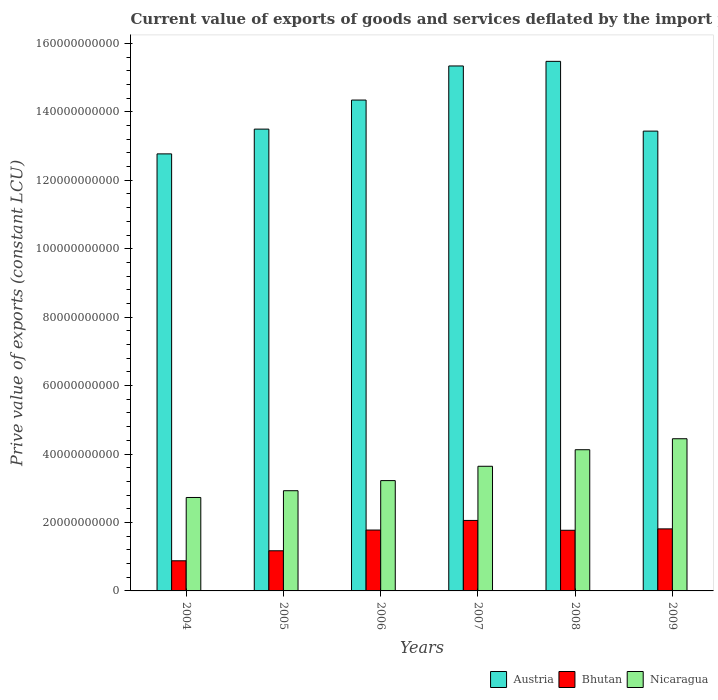How many different coloured bars are there?
Make the answer very short. 3. How many groups of bars are there?
Make the answer very short. 6. How many bars are there on the 1st tick from the right?
Offer a very short reply. 3. What is the prive value of exports in Bhutan in 2005?
Provide a short and direct response. 1.17e+1. Across all years, what is the maximum prive value of exports in Bhutan?
Give a very brief answer. 2.06e+1. Across all years, what is the minimum prive value of exports in Bhutan?
Your answer should be compact. 8.81e+09. In which year was the prive value of exports in Nicaragua maximum?
Provide a succinct answer. 2009. What is the total prive value of exports in Nicaragua in the graph?
Give a very brief answer. 2.11e+11. What is the difference between the prive value of exports in Nicaragua in 2008 and that in 2009?
Make the answer very short. -3.21e+09. What is the difference between the prive value of exports in Nicaragua in 2008 and the prive value of exports in Bhutan in 2009?
Your answer should be very brief. 2.31e+1. What is the average prive value of exports in Austria per year?
Ensure brevity in your answer.  1.41e+11. In the year 2006, what is the difference between the prive value of exports in Austria and prive value of exports in Bhutan?
Offer a terse response. 1.26e+11. In how many years, is the prive value of exports in Austria greater than 140000000000 LCU?
Offer a very short reply. 3. What is the ratio of the prive value of exports in Bhutan in 2007 to that in 2008?
Give a very brief answer. 1.16. Is the difference between the prive value of exports in Austria in 2004 and 2006 greater than the difference between the prive value of exports in Bhutan in 2004 and 2006?
Ensure brevity in your answer.  No. What is the difference between the highest and the second highest prive value of exports in Austria?
Ensure brevity in your answer.  1.35e+09. What is the difference between the highest and the lowest prive value of exports in Austria?
Provide a succinct answer. 2.70e+1. What does the 2nd bar from the left in 2008 represents?
Your answer should be compact. Bhutan. How many bars are there?
Offer a very short reply. 18. Are the values on the major ticks of Y-axis written in scientific E-notation?
Give a very brief answer. No. Does the graph contain grids?
Your response must be concise. No. How are the legend labels stacked?
Provide a succinct answer. Horizontal. What is the title of the graph?
Offer a terse response. Current value of exports of goods and services deflated by the import price index. What is the label or title of the X-axis?
Keep it short and to the point. Years. What is the label or title of the Y-axis?
Offer a very short reply. Prive value of exports (constant LCU). What is the Prive value of exports (constant LCU) of Austria in 2004?
Offer a terse response. 1.28e+11. What is the Prive value of exports (constant LCU) in Bhutan in 2004?
Offer a terse response. 8.81e+09. What is the Prive value of exports (constant LCU) of Nicaragua in 2004?
Keep it short and to the point. 2.73e+1. What is the Prive value of exports (constant LCU) of Austria in 2005?
Offer a terse response. 1.35e+11. What is the Prive value of exports (constant LCU) in Bhutan in 2005?
Provide a succinct answer. 1.17e+1. What is the Prive value of exports (constant LCU) in Nicaragua in 2005?
Ensure brevity in your answer.  2.93e+1. What is the Prive value of exports (constant LCU) in Austria in 2006?
Provide a succinct answer. 1.43e+11. What is the Prive value of exports (constant LCU) in Bhutan in 2006?
Your answer should be compact. 1.78e+1. What is the Prive value of exports (constant LCU) of Nicaragua in 2006?
Keep it short and to the point. 3.22e+1. What is the Prive value of exports (constant LCU) of Austria in 2007?
Your answer should be compact. 1.53e+11. What is the Prive value of exports (constant LCU) in Bhutan in 2007?
Make the answer very short. 2.06e+1. What is the Prive value of exports (constant LCU) in Nicaragua in 2007?
Your answer should be very brief. 3.64e+1. What is the Prive value of exports (constant LCU) in Austria in 2008?
Your response must be concise. 1.55e+11. What is the Prive value of exports (constant LCU) of Bhutan in 2008?
Keep it short and to the point. 1.77e+1. What is the Prive value of exports (constant LCU) in Nicaragua in 2008?
Provide a succinct answer. 4.13e+1. What is the Prive value of exports (constant LCU) in Austria in 2009?
Your answer should be compact. 1.34e+11. What is the Prive value of exports (constant LCU) in Bhutan in 2009?
Give a very brief answer. 1.81e+1. What is the Prive value of exports (constant LCU) in Nicaragua in 2009?
Provide a short and direct response. 4.45e+1. Across all years, what is the maximum Prive value of exports (constant LCU) of Austria?
Ensure brevity in your answer.  1.55e+11. Across all years, what is the maximum Prive value of exports (constant LCU) of Bhutan?
Your answer should be very brief. 2.06e+1. Across all years, what is the maximum Prive value of exports (constant LCU) in Nicaragua?
Offer a very short reply. 4.45e+1. Across all years, what is the minimum Prive value of exports (constant LCU) in Austria?
Provide a succinct answer. 1.28e+11. Across all years, what is the minimum Prive value of exports (constant LCU) in Bhutan?
Give a very brief answer. 8.81e+09. Across all years, what is the minimum Prive value of exports (constant LCU) in Nicaragua?
Provide a succinct answer. 2.73e+1. What is the total Prive value of exports (constant LCU) in Austria in the graph?
Offer a terse response. 8.49e+11. What is the total Prive value of exports (constant LCU) of Bhutan in the graph?
Offer a terse response. 9.48e+1. What is the total Prive value of exports (constant LCU) of Nicaragua in the graph?
Your response must be concise. 2.11e+11. What is the difference between the Prive value of exports (constant LCU) in Austria in 2004 and that in 2005?
Give a very brief answer. -7.24e+09. What is the difference between the Prive value of exports (constant LCU) in Bhutan in 2004 and that in 2005?
Your response must be concise. -2.92e+09. What is the difference between the Prive value of exports (constant LCU) in Nicaragua in 2004 and that in 2005?
Provide a short and direct response. -1.97e+09. What is the difference between the Prive value of exports (constant LCU) in Austria in 2004 and that in 2006?
Offer a terse response. -1.57e+1. What is the difference between the Prive value of exports (constant LCU) of Bhutan in 2004 and that in 2006?
Provide a succinct answer. -8.99e+09. What is the difference between the Prive value of exports (constant LCU) of Nicaragua in 2004 and that in 2006?
Your answer should be very brief. -4.93e+09. What is the difference between the Prive value of exports (constant LCU) in Austria in 2004 and that in 2007?
Your answer should be very brief. -2.57e+1. What is the difference between the Prive value of exports (constant LCU) of Bhutan in 2004 and that in 2007?
Give a very brief answer. -1.18e+1. What is the difference between the Prive value of exports (constant LCU) of Nicaragua in 2004 and that in 2007?
Ensure brevity in your answer.  -9.12e+09. What is the difference between the Prive value of exports (constant LCU) in Austria in 2004 and that in 2008?
Make the answer very short. -2.70e+1. What is the difference between the Prive value of exports (constant LCU) of Bhutan in 2004 and that in 2008?
Keep it short and to the point. -8.92e+09. What is the difference between the Prive value of exports (constant LCU) in Nicaragua in 2004 and that in 2008?
Your answer should be compact. -1.40e+1. What is the difference between the Prive value of exports (constant LCU) of Austria in 2004 and that in 2009?
Make the answer very short. -6.66e+09. What is the difference between the Prive value of exports (constant LCU) in Bhutan in 2004 and that in 2009?
Keep it short and to the point. -9.32e+09. What is the difference between the Prive value of exports (constant LCU) in Nicaragua in 2004 and that in 2009?
Provide a short and direct response. -1.72e+1. What is the difference between the Prive value of exports (constant LCU) of Austria in 2005 and that in 2006?
Provide a short and direct response. -8.49e+09. What is the difference between the Prive value of exports (constant LCU) in Bhutan in 2005 and that in 2006?
Offer a terse response. -6.06e+09. What is the difference between the Prive value of exports (constant LCU) in Nicaragua in 2005 and that in 2006?
Provide a short and direct response. -2.96e+09. What is the difference between the Prive value of exports (constant LCU) of Austria in 2005 and that in 2007?
Your response must be concise. -1.85e+1. What is the difference between the Prive value of exports (constant LCU) in Bhutan in 2005 and that in 2007?
Make the answer very short. -8.87e+09. What is the difference between the Prive value of exports (constant LCU) in Nicaragua in 2005 and that in 2007?
Keep it short and to the point. -7.14e+09. What is the difference between the Prive value of exports (constant LCU) in Austria in 2005 and that in 2008?
Keep it short and to the point. -1.98e+1. What is the difference between the Prive value of exports (constant LCU) of Bhutan in 2005 and that in 2008?
Keep it short and to the point. -5.99e+09. What is the difference between the Prive value of exports (constant LCU) in Nicaragua in 2005 and that in 2008?
Your answer should be very brief. -1.20e+1. What is the difference between the Prive value of exports (constant LCU) of Austria in 2005 and that in 2009?
Keep it short and to the point. 5.83e+08. What is the difference between the Prive value of exports (constant LCU) in Bhutan in 2005 and that in 2009?
Offer a very short reply. -6.40e+09. What is the difference between the Prive value of exports (constant LCU) of Nicaragua in 2005 and that in 2009?
Ensure brevity in your answer.  -1.52e+1. What is the difference between the Prive value of exports (constant LCU) in Austria in 2006 and that in 2007?
Offer a very short reply. -9.96e+09. What is the difference between the Prive value of exports (constant LCU) in Bhutan in 2006 and that in 2007?
Offer a very short reply. -2.81e+09. What is the difference between the Prive value of exports (constant LCU) in Nicaragua in 2006 and that in 2007?
Your response must be concise. -4.19e+09. What is the difference between the Prive value of exports (constant LCU) of Austria in 2006 and that in 2008?
Give a very brief answer. -1.13e+1. What is the difference between the Prive value of exports (constant LCU) in Bhutan in 2006 and that in 2008?
Keep it short and to the point. 7.04e+07. What is the difference between the Prive value of exports (constant LCU) of Nicaragua in 2006 and that in 2008?
Your answer should be very brief. -9.02e+09. What is the difference between the Prive value of exports (constant LCU) in Austria in 2006 and that in 2009?
Your answer should be compact. 9.08e+09. What is the difference between the Prive value of exports (constant LCU) in Bhutan in 2006 and that in 2009?
Ensure brevity in your answer.  -3.35e+08. What is the difference between the Prive value of exports (constant LCU) in Nicaragua in 2006 and that in 2009?
Offer a terse response. -1.22e+1. What is the difference between the Prive value of exports (constant LCU) of Austria in 2007 and that in 2008?
Ensure brevity in your answer.  -1.35e+09. What is the difference between the Prive value of exports (constant LCU) in Bhutan in 2007 and that in 2008?
Your answer should be very brief. 2.88e+09. What is the difference between the Prive value of exports (constant LCU) in Nicaragua in 2007 and that in 2008?
Your answer should be very brief. -4.84e+09. What is the difference between the Prive value of exports (constant LCU) in Austria in 2007 and that in 2009?
Your answer should be very brief. 1.90e+1. What is the difference between the Prive value of exports (constant LCU) in Bhutan in 2007 and that in 2009?
Your response must be concise. 2.47e+09. What is the difference between the Prive value of exports (constant LCU) in Nicaragua in 2007 and that in 2009?
Offer a very short reply. -8.05e+09. What is the difference between the Prive value of exports (constant LCU) in Austria in 2008 and that in 2009?
Give a very brief answer. 2.04e+1. What is the difference between the Prive value of exports (constant LCU) of Bhutan in 2008 and that in 2009?
Offer a terse response. -4.05e+08. What is the difference between the Prive value of exports (constant LCU) of Nicaragua in 2008 and that in 2009?
Provide a succinct answer. -3.21e+09. What is the difference between the Prive value of exports (constant LCU) in Austria in 2004 and the Prive value of exports (constant LCU) in Bhutan in 2005?
Make the answer very short. 1.16e+11. What is the difference between the Prive value of exports (constant LCU) in Austria in 2004 and the Prive value of exports (constant LCU) in Nicaragua in 2005?
Provide a succinct answer. 9.84e+1. What is the difference between the Prive value of exports (constant LCU) in Bhutan in 2004 and the Prive value of exports (constant LCU) in Nicaragua in 2005?
Offer a terse response. -2.05e+1. What is the difference between the Prive value of exports (constant LCU) in Austria in 2004 and the Prive value of exports (constant LCU) in Bhutan in 2006?
Your answer should be very brief. 1.10e+11. What is the difference between the Prive value of exports (constant LCU) of Austria in 2004 and the Prive value of exports (constant LCU) of Nicaragua in 2006?
Offer a terse response. 9.55e+1. What is the difference between the Prive value of exports (constant LCU) in Bhutan in 2004 and the Prive value of exports (constant LCU) in Nicaragua in 2006?
Your response must be concise. -2.34e+1. What is the difference between the Prive value of exports (constant LCU) in Austria in 2004 and the Prive value of exports (constant LCU) in Bhutan in 2007?
Give a very brief answer. 1.07e+11. What is the difference between the Prive value of exports (constant LCU) of Austria in 2004 and the Prive value of exports (constant LCU) of Nicaragua in 2007?
Your response must be concise. 9.13e+1. What is the difference between the Prive value of exports (constant LCU) of Bhutan in 2004 and the Prive value of exports (constant LCU) of Nicaragua in 2007?
Offer a very short reply. -2.76e+1. What is the difference between the Prive value of exports (constant LCU) of Austria in 2004 and the Prive value of exports (constant LCU) of Bhutan in 2008?
Your answer should be compact. 1.10e+11. What is the difference between the Prive value of exports (constant LCU) of Austria in 2004 and the Prive value of exports (constant LCU) of Nicaragua in 2008?
Your answer should be very brief. 8.65e+1. What is the difference between the Prive value of exports (constant LCU) in Bhutan in 2004 and the Prive value of exports (constant LCU) in Nicaragua in 2008?
Provide a short and direct response. -3.25e+1. What is the difference between the Prive value of exports (constant LCU) of Austria in 2004 and the Prive value of exports (constant LCU) of Bhutan in 2009?
Provide a short and direct response. 1.10e+11. What is the difference between the Prive value of exports (constant LCU) in Austria in 2004 and the Prive value of exports (constant LCU) in Nicaragua in 2009?
Your response must be concise. 8.32e+1. What is the difference between the Prive value of exports (constant LCU) in Bhutan in 2004 and the Prive value of exports (constant LCU) in Nicaragua in 2009?
Offer a terse response. -3.57e+1. What is the difference between the Prive value of exports (constant LCU) of Austria in 2005 and the Prive value of exports (constant LCU) of Bhutan in 2006?
Your answer should be compact. 1.17e+11. What is the difference between the Prive value of exports (constant LCU) of Austria in 2005 and the Prive value of exports (constant LCU) of Nicaragua in 2006?
Offer a very short reply. 1.03e+11. What is the difference between the Prive value of exports (constant LCU) in Bhutan in 2005 and the Prive value of exports (constant LCU) in Nicaragua in 2006?
Keep it short and to the point. -2.05e+1. What is the difference between the Prive value of exports (constant LCU) in Austria in 2005 and the Prive value of exports (constant LCU) in Bhutan in 2007?
Provide a succinct answer. 1.14e+11. What is the difference between the Prive value of exports (constant LCU) in Austria in 2005 and the Prive value of exports (constant LCU) in Nicaragua in 2007?
Ensure brevity in your answer.  9.85e+1. What is the difference between the Prive value of exports (constant LCU) in Bhutan in 2005 and the Prive value of exports (constant LCU) in Nicaragua in 2007?
Your response must be concise. -2.47e+1. What is the difference between the Prive value of exports (constant LCU) of Austria in 2005 and the Prive value of exports (constant LCU) of Bhutan in 2008?
Give a very brief answer. 1.17e+11. What is the difference between the Prive value of exports (constant LCU) in Austria in 2005 and the Prive value of exports (constant LCU) in Nicaragua in 2008?
Keep it short and to the point. 9.37e+1. What is the difference between the Prive value of exports (constant LCU) of Bhutan in 2005 and the Prive value of exports (constant LCU) of Nicaragua in 2008?
Ensure brevity in your answer.  -2.95e+1. What is the difference between the Prive value of exports (constant LCU) in Austria in 2005 and the Prive value of exports (constant LCU) in Bhutan in 2009?
Give a very brief answer. 1.17e+11. What is the difference between the Prive value of exports (constant LCU) in Austria in 2005 and the Prive value of exports (constant LCU) in Nicaragua in 2009?
Make the answer very short. 9.05e+1. What is the difference between the Prive value of exports (constant LCU) of Bhutan in 2005 and the Prive value of exports (constant LCU) of Nicaragua in 2009?
Offer a very short reply. -3.27e+1. What is the difference between the Prive value of exports (constant LCU) of Austria in 2006 and the Prive value of exports (constant LCU) of Bhutan in 2007?
Your response must be concise. 1.23e+11. What is the difference between the Prive value of exports (constant LCU) of Austria in 2006 and the Prive value of exports (constant LCU) of Nicaragua in 2007?
Make the answer very short. 1.07e+11. What is the difference between the Prive value of exports (constant LCU) in Bhutan in 2006 and the Prive value of exports (constant LCU) in Nicaragua in 2007?
Offer a very short reply. -1.86e+1. What is the difference between the Prive value of exports (constant LCU) in Austria in 2006 and the Prive value of exports (constant LCU) in Bhutan in 2008?
Make the answer very short. 1.26e+11. What is the difference between the Prive value of exports (constant LCU) of Austria in 2006 and the Prive value of exports (constant LCU) of Nicaragua in 2008?
Make the answer very short. 1.02e+11. What is the difference between the Prive value of exports (constant LCU) of Bhutan in 2006 and the Prive value of exports (constant LCU) of Nicaragua in 2008?
Ensure brevity in your answer.  -2.35e+1. What is the difference between the Prive value of exports (constant LCU) of Austria in 2006 and the Prive value of exports (constant LCU) of Bhutan in 2009?
Make the answer very short. 1.25e+11. What is the difference between the Prive value of exports (constant LCU) of Austria in 2006 and the Prive value of exports (constant LCU) of Nicaragua in 2009?
Make the answer very short. 9.90e+1. What is the difference between the Prive value of exports (constant LCU) of Bhutan in 2006 and the Prive value of exports (constant LCU) of Nicaragua in 2009?
Your answer should be very brief. -2.67e+1. What is the difference between the Prive value of exports (constant LCU) of Austria in 2007 and the Prive value of exports (constant LCU) of Bhutan in 2008?
Your answer should be compact. 1.36e+11. What is the difference between the Prive value of exports (constant LCU) in Austria in 2007 and the Prive value of exports (constant LCU) in Nicaragua in 2008?
Make the answer very short. 1.12e+11. What is the difference between the Prive value of exports (constant LCU) of Bhutan in 2007 and the Prive value of exports (constant LCU) of Nicaragua in 2008?
Keep it short and to the point. -2.07e+1. What is the difference between the Prive value of exports (constant LCU) in Austria in 2007 and the Prive value of exports (constant LCU) in Bhutan in 2009?
Your answer should be compact. 1.35e+11. What is the difference between the Prive value of exports (constant LCU) of Austria in 2007 and the Prive value of exports (constant LCU) of Nicaragua in 2009?
Keep it short and to the point. 1.09e+11. What is the difference between the Prive value of exports (constant LCU) in Bhutan in 2007 and the Prive value of exports (constant LCU) in Nicaragua in 2009?
Provide a short and direct response. -2.39e+1. What is the difference between the Prive value of exports (constant LCU) in Austria in 2008 and the Prive value of exports (constant LCU) in Bhutan in 2009?
Your answer should be compact. 1.37e+11. What is the difference between the Prive value of exports (constant LCU) in Austria in 2008 and the Prive value of exports (constant LCU) in Nicaragua in 2009?
Your response must be concise. 1.10e+11. What is the difference between the Prive value of exports (constant LCU) in Bhutan in 2008 and the Prive value of exports (constant LCU) in Nicaragua in 2009?
Give a very brief answer. -2.68e+1. What is the average Prive value of exports (constant LCU) in Austria per year?
Ensure brevity in your answer.  1.41e+11. What is the average Prive value of exports (constant LCU) in Bhutan per year?
Keep it short and to the point. 1.58e+1. What is the average Prive value of exports (constant LCU) in Nicaragua per year?
Offer a very short reply. 3.52e+1. In the year 2004, what is the difference between the Prive value of exports (constant LCU) of Austria and Prive value of exports (constant LCU) of Bhutan?
Offer a terse response. 1.19e+11. In the year 2004, what is the difference between the Prive value of exports (constant LCU) in Austria and Prive value of exports (constant LCU) in Nicaragua?
Give a very brief answer. 1.00e+11. In the year 2004, what is the difference between the Prive value of exports (constant LCU) in Bhutan and Prive value of exports (constant LCU) in Nicaragua?
Offer a terse response. -1.85e+1. In the year 2005, what is the difference between the Prive value of exports (constant LCU) of Austria and Prive value of exports (constant LCU) of Bhutan?
Your answer should be very brief. 1.23e+11. In the year 2005, what is the difference between the Prive value of exports (constant LCU) of Austria and Prive value of exports (constant LCU) of Nicaragua?
Your answer should be very brief. 1.06e+11. In the year 2005, what is the difference between the Prive value of exports (constant LCU) in Bhutan and Prive value of exports (constant LCU) in Nicaragua?
Make the answer very short. -1.76e+1. In the year 2006, what is the difference between the Prive value of exports (constant LCU) of Austria and Prive value of exports (constant LCU) of Bhutan?
Provide a succinct answer. 1.26e+11. In the year 2006, what is the difference between the Prive value of exports (constant LCU) in Austria and Prive value of exports (constant LCU) in Nicaragua?
Keep it short and to the point. 1.11e+11. In the year 2006, what is the difference between the Prive value of exports (constant LCU) in Bhutan and Prive value of exports (constant LCU) in Nicaragua?
Make the answer very short. -1.44e+1. In the year 2007, what is the difference between the Prive value of exports (constant LCU) of Austria and Prive value of exports (constant LCU) of Bhutan?
Make the answer very short. 1.33e+11. In the year 2007, what is the difference between the Prive value of exports (constant LCU) of Austria and Prive value of exports (constant LCU) of Nicaragua?
Provide a short and direct response. 1.17e+11. In the year 2007, what is the difference between the Prive value of exports (constant LCU) of Bhutan and Prive value of exports (constant LCU) of Nicaragua?
Make the answer very short. -1.58e+1. In the year 2008, what is the difference between the Prive value of exports (constant LCU) in Austria and Prive value of exports (constant LCU) in Bhutan?
Your answer should be compact. 1.37e+11. In the year 2008, what is the difference between the Prive value of exports (constant LCU) in Austria and Prive value of exports (constant LCU) in Nicaragua?
Keep it short and to the point. 1.13e+11. In the year 2008, what is the difference between the Prive value of exports (constant LCU) in Bhutan and Prive value of exports (constant LCU) in Nicaragua?
Give a very brief answer. -2.35e+1. In the year 2009, what is the difference between the Prive value of exports (constant LCU) of Austria and Prive value of exports (constant LCU) of Bhutan?
Your response must be concise. 1.16e+11. In the year 2009, what is the difference between the Prive value of exports (constant LCU) in Austria and Prive value of exports (constant LCU) in Nicaragua?
Provide a succinct answer. 8.99e+1. In the year 2009, what is the difference between the Prive value of exports (constant LCU) of Bhutan and Prive value of exports (constant LCU) of Nicaragua?
Offer a terse response. -2.63e+1. What is the ratio of the Prive value of exports (constant LCU) in Austria in 2004 to that in 2005?
Ensure brevity in your answer.  0.95. What is the ratio of the Prive value of exports (constant LCU) of Bhutan in 2004 to that in 2005?
Keep it short and to the point. 0.75. What is the ratio of the Prive value of exports (constant LCU) in Nicaragua in 2004 to that in 2005?
Give a very brief answer. 0.93. What is the ratio of the Prive value of exports (constant LCU) in Austria in 2004 to that in 2006?
Offer a terse response. 0.89. What is the ratio of the Prive value of exports (constant LCU) of Bhutan in 2004 to that in 2006?
Your answer should be compact. 0.49. What is the ratio of the Prive value of exports (constant LCU) of Nicaragua in 2004 to that in 2006?
Make the answer very short. 0.85. What is the ratio of the Prive value of exports (constant LCU) of Austria in 2004 to that in 2007?
Give a very brief answer. 0.83. What is the ratio of the Prive value of exports (constant LCU) of Bhutan in 2004 to that in 2007?
Provide a succinct answer. 0.43. What is the ratio of the Prive value of exports (constant LCU) in Nicaragua in 2004 to that in 2007?
Your response must be concise. 0.75. What is the ratio of the Prive value of exports (constant LCU) of Austria in 2004 to that in 2008?
Your answer should be very brief. 0.83. What is the ratio of the Prive value of exports (constant LCU) in Bhutan in 2004 to that in 2008?
Ensure brevity in your answer.  0.5. What is the ratio of the Prive value of exports (constant LCU) of Nicaragua in 2004 to that in 2008?
Offer a very short reply. 0.66. What is the ratio of the Prive value of exports (constant LCU) in Austria in 2004 to that in 2009?
Offer a very short reply. 0.95. What is the ratio of the Prive value of exports (constant LCU) of Bhutan in 2004 to that in 2009?
Give a very brief answer. 0.49. What is the ratio of the Prive value of exports (constant LCU) in Nicaragua in 2004 to that in 2009?
Provide a short and direct response. 0.61. What is the ratio of the Prive value of exports (constant LCU) of Austria in 2005 to that in 2006?
Your response must be concise. 0.94. What is the ratio of the Prive value of exports (constant LCU) of Bhutan in 2005 to that in 2006?
Provide a short and direct response. 0.66. What is the ratio of the Prive value of exports (constant LCU) in Nicaragua in 2005 to that in 2006?
Your answer should be compact. 0.91. What is the ratio of the Prive value of exports (constant LCU) of Austria in 2005 to that in 2007?
Make the answer very short. 0.88. What is the ratio of the Prive value of exports (constant LCU) in Bhutan in 2005 to that in 2007?
Your answer should be very brief. 0.57. What is the ratio of the Prive value of exports (constant LCU) in Nicaragua in 2005 to that in 2007?
Make the answer very short. 0.8. What is the ratio of the Prive value of exports (constant LCU) in Austria in 2005 to that in 2008?
Offer a very short reply. 0.87. What is the ratio of the Prive value of exports (constant LCU) of Bhutan in 2005 to that in 2008?
Your response must be concise. 0.66. What is the ratio of the Prive value of exports (constant LCU) of Nicaragua in 2005 to that in 2008?
Provide a succinct answer. 0.71. What is the ratio of the Prive value of exports (constant LCU) in Austria in 2005 to that in 2009?
Provide a short and direct response. 1. What is the ratio of the Prive value of exports (constant LCU) of Bhutan in 2005 to that in 2009?
Your answer should be very brief. 0.65. What is the ratio of the Prive value of exports (constant LCU) of Nicaragua in 2005 to that in 2009?
Give a very brief answer. 0.66. What is the ratio of the Prive value of exports (constant LCU) of Austria in 2006 to that in 2007?
Provide a succinct answer. 0.94. What is the ratio of the Prive value of exports (constant LCU) in Bhutan in 2006 to that in 2007?
Make the answer very short. 0.86. What is the ratio of the Prive value of exports (constant LCU) in Nicaragua in 2006 to that in 2007?
Provide a short and direct response. 0.89. What is the ratio of the Prive value of exports (constant LCU) of Austria in 2006 to that in 2008?
Offer a terse response. 0.93. What is the ratio of the Prive value of exports (constant LCU) in Nicaragua in 2006 to that in 2008?
Provide a short and direct response. 0.78. What is the ratio of the Prive value of exports (constant LCU) of Austria in 2006 to that in 2009?
Your response must be concise. 1.07. What is the ratio of the Prive value of exports (constant LCU) in Bhutan in 2006 to that in 2009?
Offer a terse response. 0.98. What is the ratio of the Prive value of exports (constant LCU) of Nicaragua in 2006 to that in 2009?
Your answer should be very brief. 0.72. What is the ratio of the Prive value of exports (constant LCU) in Bhutan in 2007 to that in 2008?
Give a very brief answer. 1.16. What is the ratio of the Prive value of exports (constant LCU) in Nicaragua in 2007 to that in 2008?
Provide a succinct answer. 0.88. What is the ratio of the Prive value of exports (constant LCU) in Austria in 2007 to that in 2009?
Your response must be concise. 1.14. What is the ratio of the Prive value of exports (constant LCU) in Bhutan in 2007 to that in 2009?
Your response must be concise. 1.14. What is the ratio of the Prive value of exports (constant LCU) of Nicaragua in 2007 to that in 2009?
Offer a very short reply. 0.82. What is the ratio of the Prive value of exports (constant LCU) of Austria in 2008 to that in 2009?
Keep it short and to the point. 1.15. What is the ratio of the Prive value of exports (constant LCU) in Bhutan in 2008 to that in 2009?
Your answer should be very brief. 0.98. What is the ratio of the Prive value of exports (constant LCU) of Nicaragua in 2008 to that in 2009?
Keep it short and to the point. 0.93. What is the difference between the highest and the second highest Prive value of exports (constant LCU) in Austria?
Offer a very short reply. 1.35e+09. What is the difference between the highest and the second highest Prive value of exports (constant LCU) in Bhutan?
Your answer should be compact. 2.47e+09. What is the difference between the highest and the second highest Prive value of exports (constant LCU) of Nicaragua?
Ensure brevity in your answer.  3.21e+09. What is the difference between the highest and the lowest Prive value of exports (constant LCU) in Austria?
Provide a succinct answer. 2.70e+1. What is the difference between the highest and the lowest Prive value of exports (constant LCU) in Bhutan?
Your answer should be very brief. 1.18e+1. What is the difference between the highest and the lowest Prive value of exports (constant LCU) of Nicaragua?
Ensure brevity in your answer.  1.72e+1. 